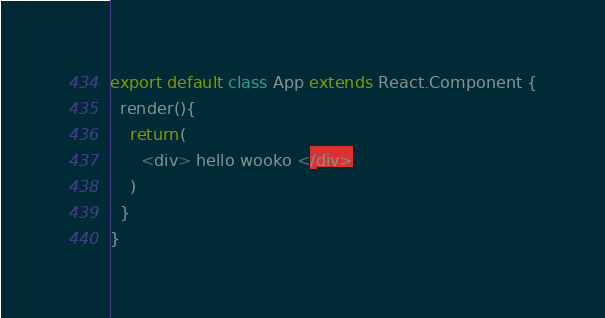<code> <loc_0><loc_0><loc_500><loc_500><_JavaScript_>export default class App extends React.Component {
  render(){
    return(
      <div> hello wooko </div>
    )
  }
}</code> 